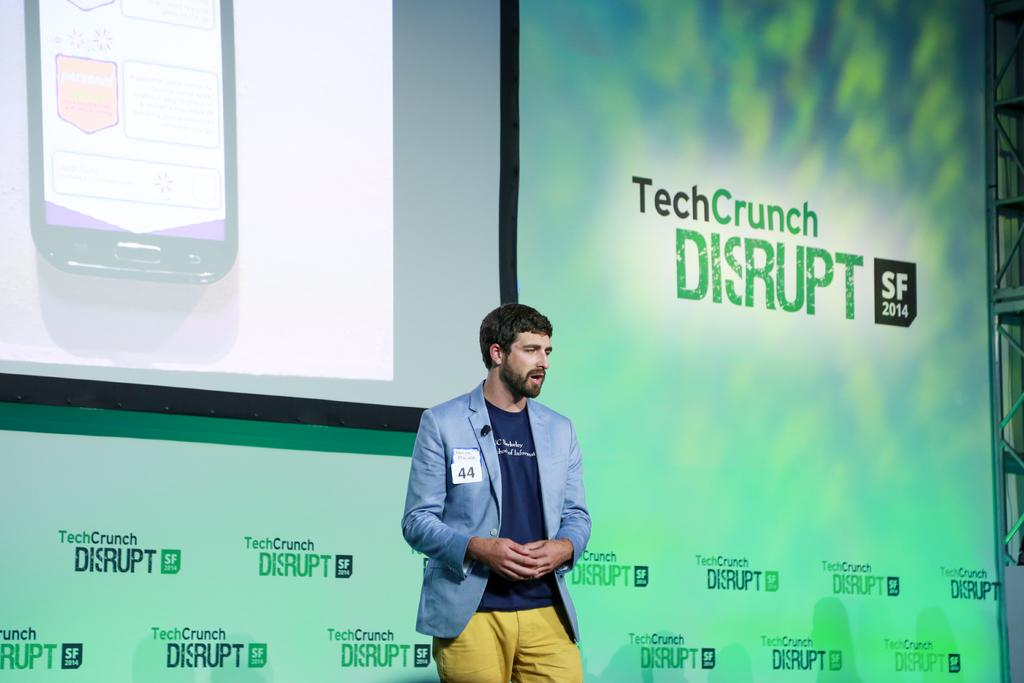What is the person in the image doing? The person is standing on a dais in the image. What can be seen in the background of the image? There is a screen and a poster in the background of the image. What type of wing is attached to the person's dress in the image? There is no wing or dress present in the image; the person is simply standing on a dais. How many nuts are visible on the poster in the image? There is no mention of nuts on the poster in the image, as the facts only mention the presence of a screen and a poster. 